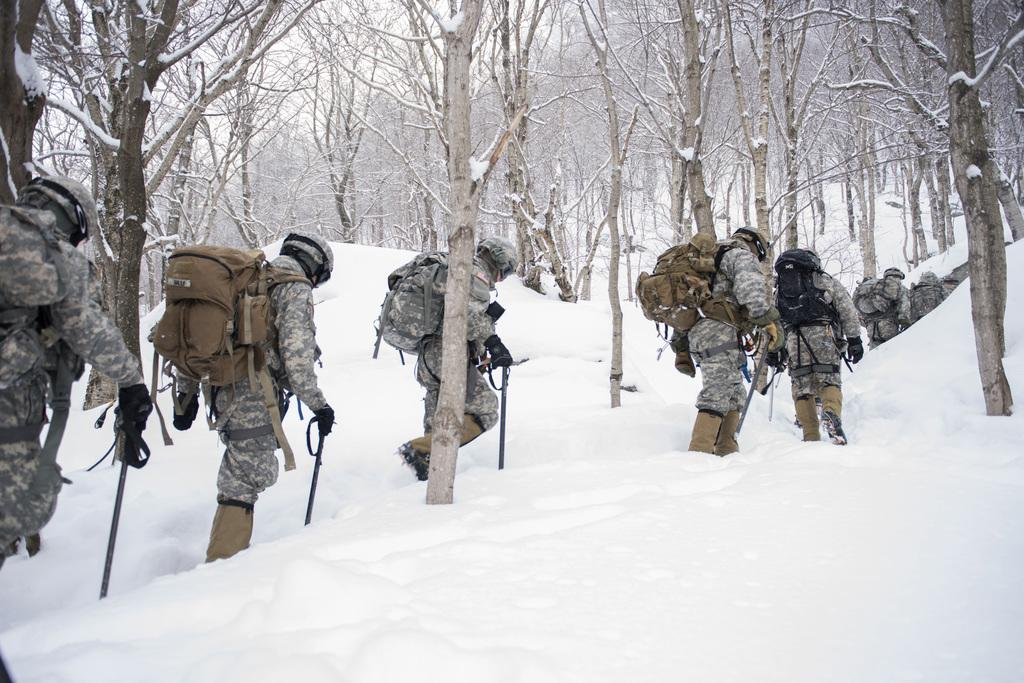How many people are in the image? There are people in the image, but the exact number is not specified. What are the people doing in the image? The people are walking in the image. What items are the people wearing? The people are wearing bags, helmets, and gloves in the image. What are the people holding in the image? The people are holding sticks in the image. What is the weather like in the image? There is snow visible in the image, indicating a cold or wintry environment. What type of vegetation is present in the image? There are trees in the image. Can you see any ghosts fighting in the image? No, there are no ghosts or fights depicted in the image. 